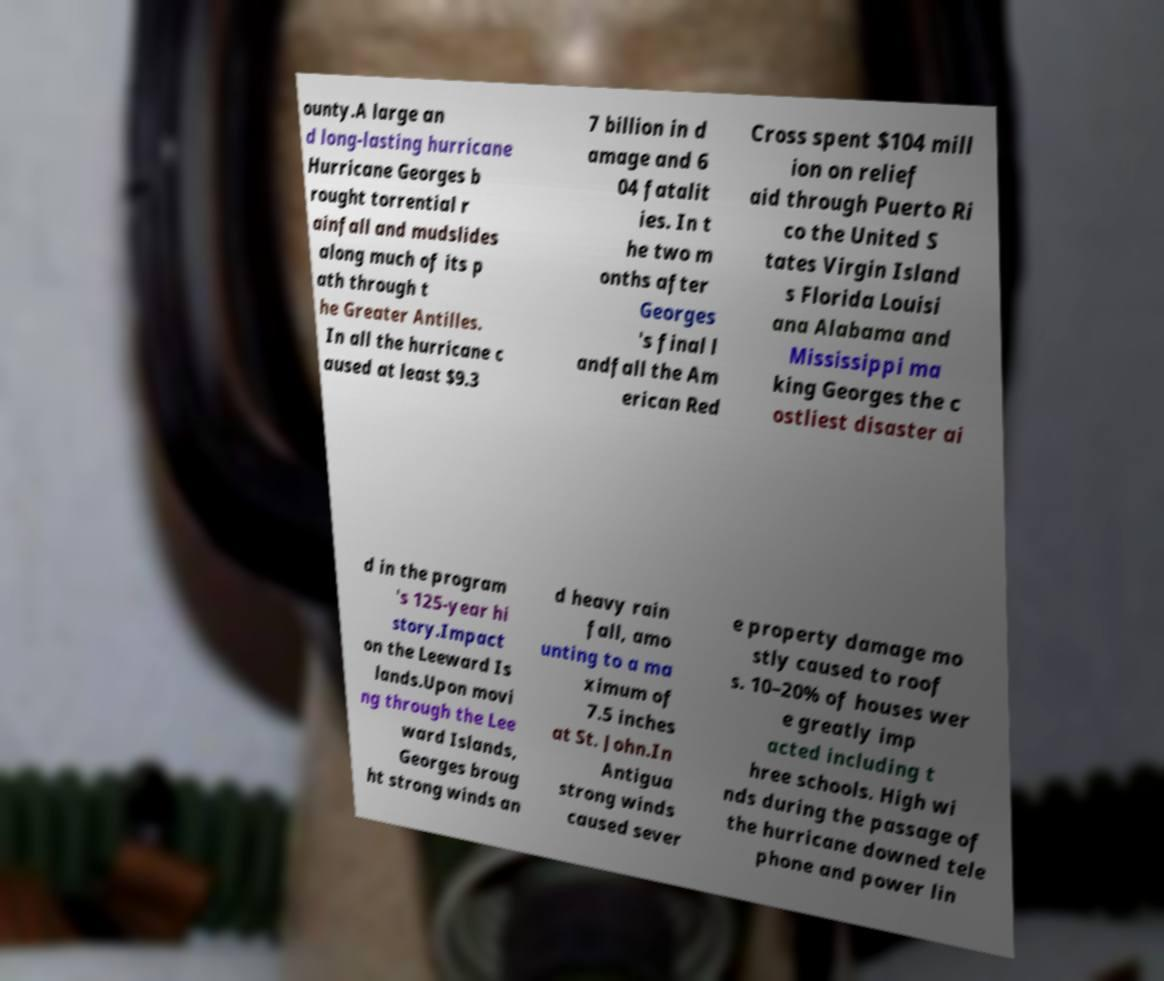For documentation purposes, I need the text within this image transcribed. Could you provide that? ounty.A large an d long-lasting hurricane Hurricane Georges b rought torrential r ainfall and mudslides along much of its p ath through t he Greater Antilles. In all the hurricane c aused at least $9.3 7 billion in d amage and 6 04 fatalit ies. In t he two m onths after Georges 's final l andfall the Am erican Red Cross spent $104 mill ion on relief aid through Puerto Ri co the United S tates Virgin Island s Florida Louisi ana Alabama and Mississippi ma king Georges the c ostliest disaster ai d in the program 's 125-year hi story.Impact on the Leeward Is lands.Upon movi ng through the Lee ward Islands, Georges broug ht strong winds an d heavy rain fall, amo unting to a ma ximum of 7.5 inches at St. John.In Antigua strong winds caused sever e property damage mo stly caused to roof s. 10–20% of houses wer e greatly imp acted including t hree schools. High wi nds during the passage of the hurricane downed tele phone and power lin 